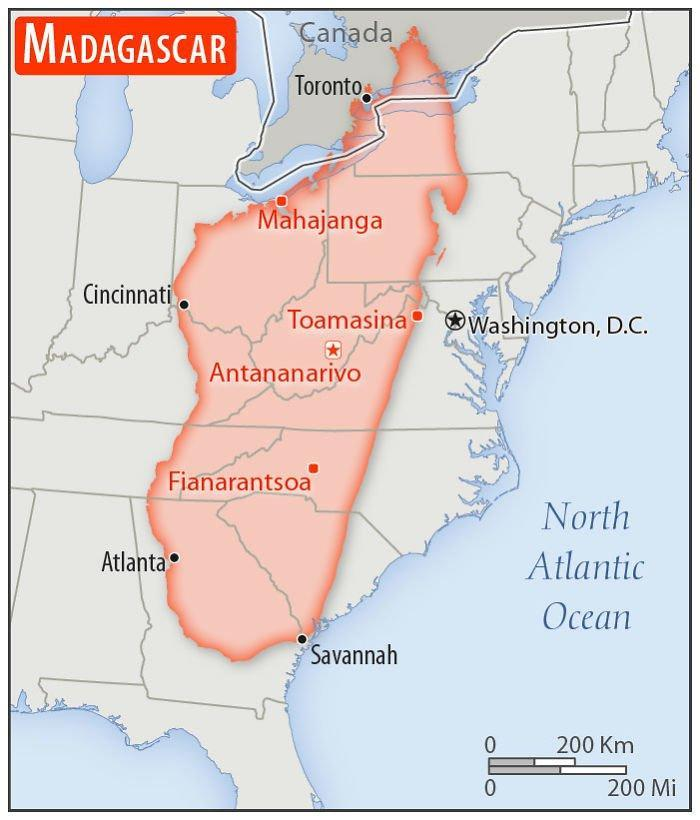How many places are written in red color ?
Answer the question with a short phrase. 4 Which place lies to the east of Toamasina in this map ? Washington, D.C. Which is the water body that lies to the east of Washington, D.C.? North Atlantic Ocean Which place lies to the west of Toamasina on this map? Cincinnati How many countries are present in this map ? 3 Which country lies to the north of Washington D.C. ? Canada 